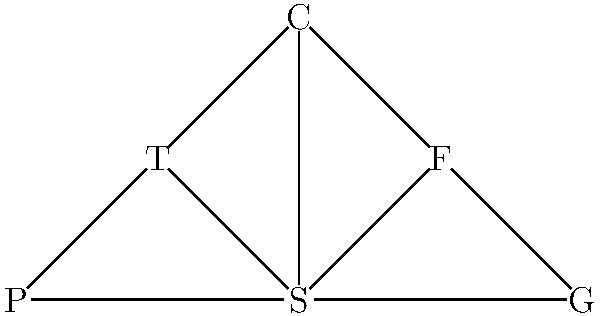In the given social support network for survivors, node S represents a survivor, and the other nodes represent different types of support (F: Friends, T: Therapist, C: Community group, P: Parents, G: Support group). If we want to ensure the survivor has at least two independent paths to each type of support for resilience, what is the minimum number of additional edges that need to be added to the network? To solve this problem, we need to follow these steps:

1. Identify the current number of independent paths from S to each support node:
   - S to F: 1 direct path
   - S to T: 1 direct path
   - S to C: 1 direct path, 1 path through F, 1 path through T (already 2 independent paths)
   - S to P: 1 direct path
   - S to G: 1 direct path

2. Determine which nodes need additional paths:
   - F needs 1 more path
   - T needs 1 more path
   - P needs 1 more path
   - G needs 1 more path

3. Add edges efficiently to create new independent paths:
   - Add F--T: This creates a new path for both F and T
   - Add P--G: This creates a new path for both P and G

4. Count the number of added edges:
   We added 2 edges (F--T and P--G) to ensure at least two independent paths from S to each support node.

Therefore, the minimum number of additional edges needed is 2.
Answer: 2 